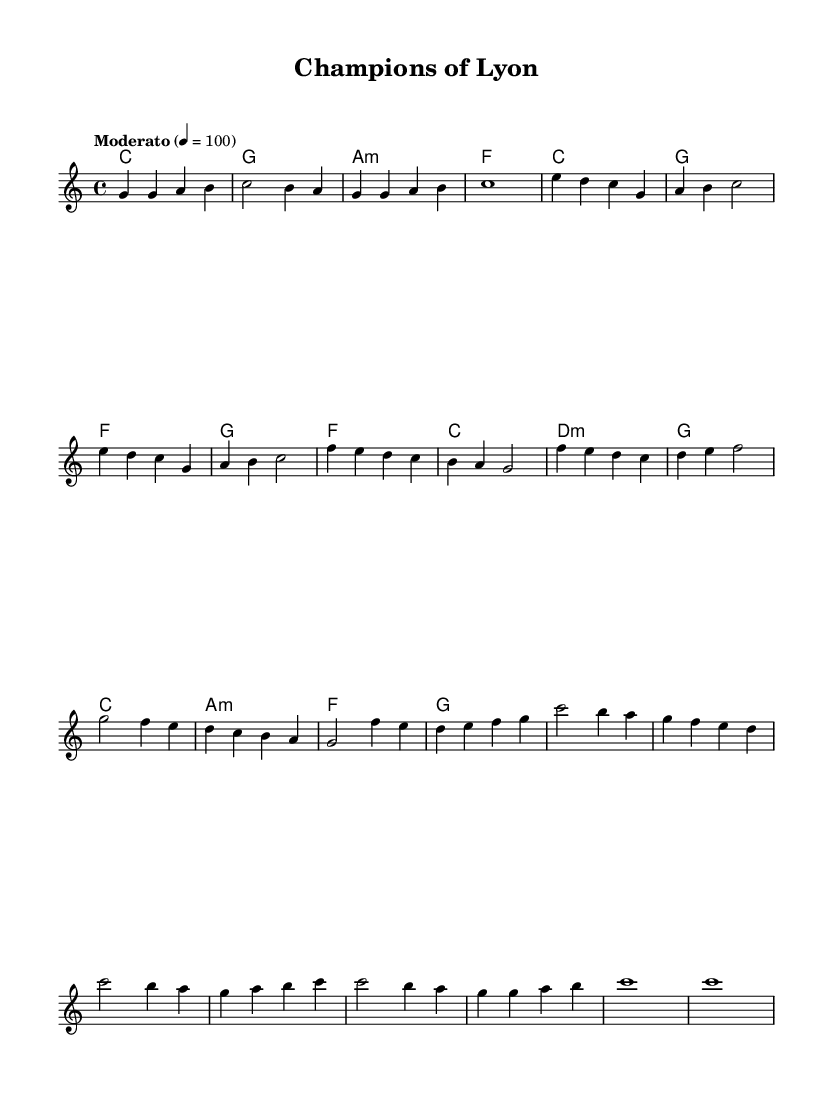What is the key signature of this music? The key signature is C major, which has no sharps or flats.
Answer: C major What is the time signature of this music? The time signature indicated at the beginning of the sheet music is 4/4, meaning there are four beats per measure.
Answer: 4/4 What is the tempo marking for this piece? The tempo marking is "Moderato," which suggests a moderate speed for the music. It indicates a tempo of 100 beats per minute.
Answer: Moderato How many distinct themes are present in the piece? The piece includes two distinct themes, referred to as Theme A and Theme B, indicated in the melody section.
Answer: 2 What is the harmonic structure of the first measure? The first measure shows a C major chord in the harmonies, indicated by the symbol "c" on the staff.
Answer: C major Which part of the music indicates a build-up? The section labeled "Build-up" features a combination of notes that progressively increase tension leading to the climax.
Answer: Build-up What is the last note type indicated in the melody? The last note type in the melody is a whole note (c1), suggesting a strong resolution at the end of the piece.
Answer: Whole note 